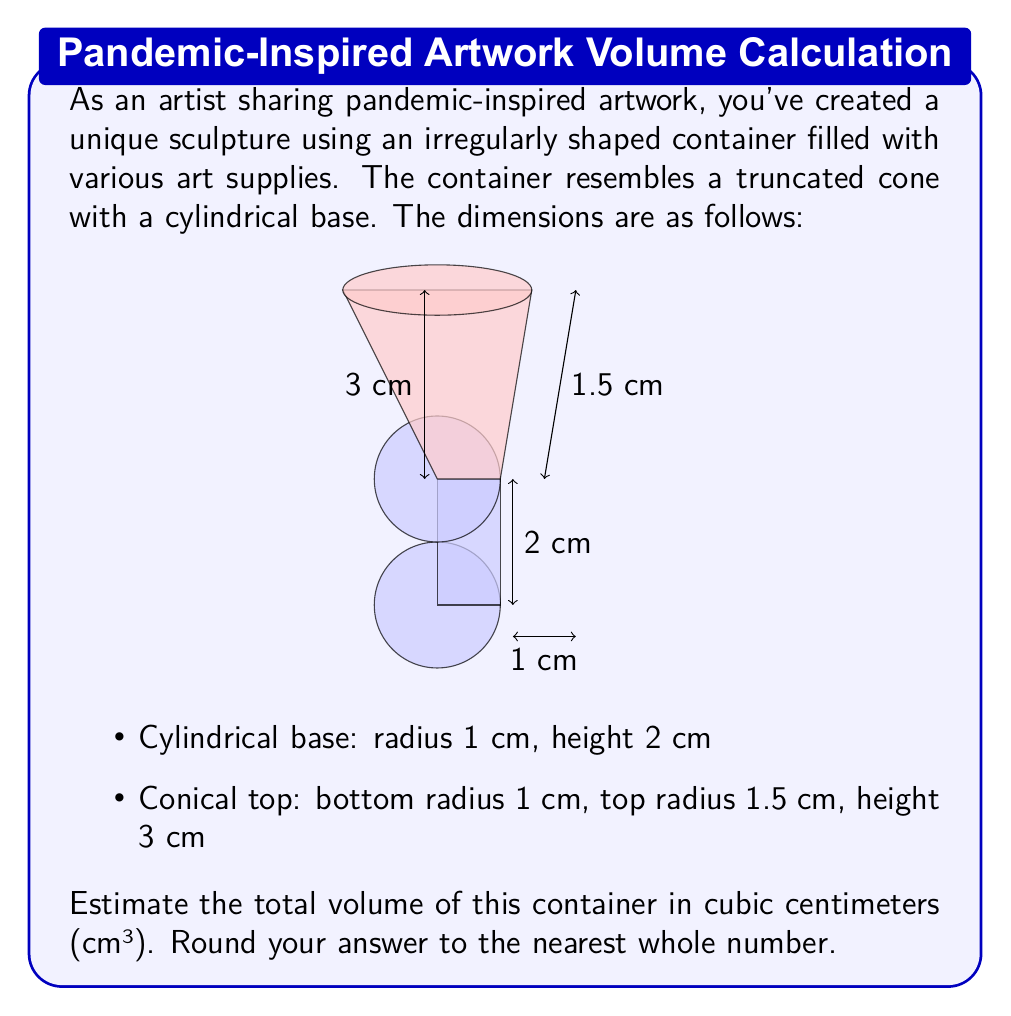Can you solve this math problem? To estimate the volume of this irregularly shaped container, we need to calculate the volumes of the cylindrical base and the truncated cone separately, then add them together.

1. Volume of the cylindrical base:
   $$V_{cylinder} = \pi r^2 h$$
   $$V_{cylinder} = \pi \cdot 1^2 \cdot 2 = 2\pi \approx 6.28 \text{ cm}^3$$

2. Volume of the truncated cone:
   The formula for the volume of a truncated cone is:
   $$V_{truncated\,cone} = \frac{1}{3}\pi h(R^2 + r^2 + Rr)$$
   where $h$ is the height, $R$ is the radius of the larger base, and $r$ is the radius of the smaller base.

   $$V_{truncated\,cone} = \frac{1}{3}\pi \cdot 3(1.5^2 + 1^2 + 1.5 \cdot 1)$$
   $$V_{truncated\,cone} = \pi(2.25 + 1 + 1.5) = 4.75\pi \approx 14.92 \text{ cm}^3$$

3. Total volume:
   $$V_{total} = V_{cylinder} + V_{truncated\,cone}$$
   $$V_{total} \approx 6.28 + 14.92 = 21.20 \text{ cm}^3$$

4. Rounding to the nearest whole number:
   $$V_{total} \approx 21 \text{ cm}^3$$
Answer: 21 cm³ 